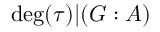Convert formula to latex. <formula><loc_0><loc_0><loc_500><loc_500>\deg ( \tau ) | ( G \colon A )</formula> 